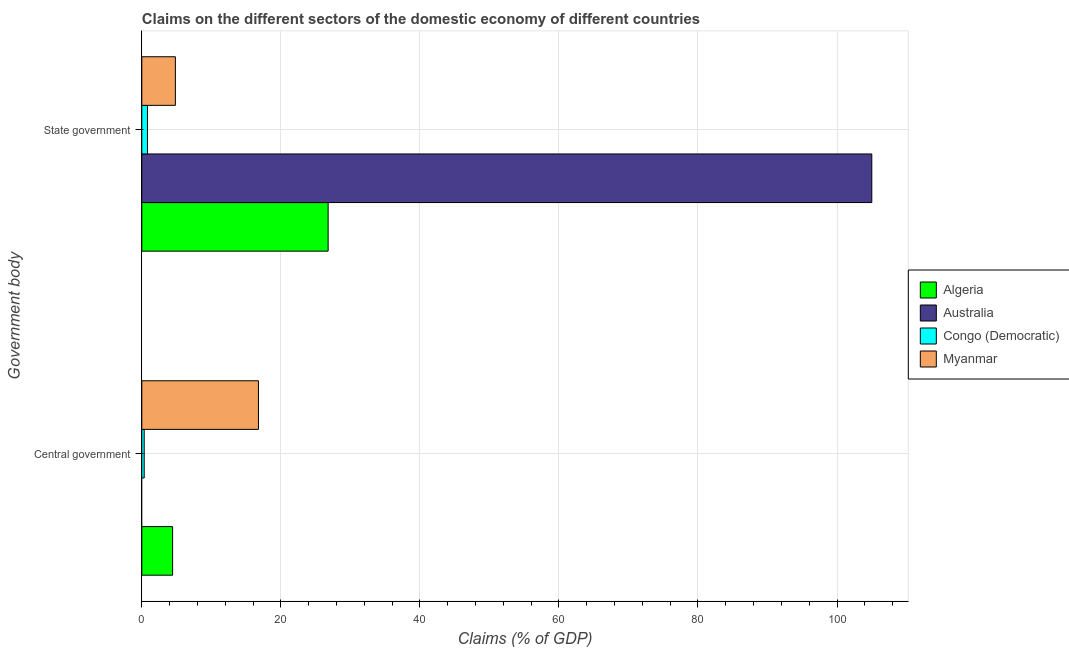How many different coloured bars are there?
Keep it short and to the point. 4. How many groups of bars are there?
Make the answer very short. 2. Are the number of bars per tick equal to the number of legend labels?
Provide a succinct answer. No. How many bars are there on the 1st tick from the bottom?
Your answer should be very brief. 3. What is the label of the 1st group of bars from the top?
Your answer should be very brief. State government. What is the claims on state government in Australia?
Ensure brevity in your answer.  105. Across all countries, what is the maximum claims on central government?
Keep it short and to the point. 16.78. Across all countries, what is the minimum claims on state government?
Provide a short and direct response. 0.81. In which country was the claims on state government maximum?
Offer a very short reply. Australia. What is the total claims on central government in the graph?
Provide a succinct answer. 21.56. What is the difference between the claims on state government in Myanmar and that in Australia?
Your response must be concise. -100.17. What is the difference between the claims on central government in Congo (Democratic) and the claims on state government in Algeria?
Make the answer very short. -26.46. What is the average claims on state government per country?
Provide a short and direct response. 34.36. What is the difference between the claims on central government and claims on state government in Congo (Democratic)?
Keep it short and to the point. -0.47. In how many countries, is the claims on central government greater than 80 %?
Ensure brevity in your answer.  0. What is the ratio of the claims on state government in Myanmar to that in Algeria?
Make the answer very short. 0.18. In how many countries, is the claims on central government greater than the average claims on central government taken over all countries?
Offer a very short reply. 1. How many bars are there?
Keep it short and to the point. 7. Are the values on the major ticks of X-axis written in scientific E-notation?
Provide a succinct answer. No. Does the graph contain grids?
Make the answer very short. Yes. Where does the legend appear in the graph?
Ensure brevity in your answer.  Center right. How many legend labels are there?
Provide a succinct answer. 4. What is the title of the graph?
Your answer should be compact. Claims on the different sectors of the domestic economy of different countries. Does "Papua New Guinea" appear as one of the legend labels in the graph?
Provide a succinct answer. No. What is the label or title of the X-axis?
Your answer should be compact. Claims (% of GDP). What is the label or title of the Y-axis?
Make the answer very short. Government body. What is the Claims (% of GDP) in Algeria in Central government?
Keep it short and to the point. 4.43. What is the Claims (% of GDP) in Congo (Democratic) in Central government?
Offer a terse response. 0.35. What is the Claims (% of GDP) of Myanmar in Central government?
Your answer should be very brief. 16.78. What is the Claims (% of GDP) of Algeria in State government?
Keep it short and to the point. 26.8. What is the Claims (% of GDP) in Australia in State government?
Provide a short and direct response. 105. What is the Claims (% of GDP) of Congo (Democratic) in State government?
Provide a short and direct response. 0.81. What is the Claims (% of GDP) in Myanmar in State government?
Offer a very short reply. 4.83. Across all Government body, what is the maximum Claims (% of GDP) in Algeria?
Keep it short and to the point. 26.8. Across all Government body, what is the maximum Claims (% of GDP) of Australia?
Your answer should be compact. 105. Across all Government body, what is the maximum Claims (% of GDP) of Congo (Democratic)?
Ensure brevity in your answer.  0.81. Across all Government body, what is the maximum Claims (% of GDP) in Myanmar?
Offer a very short reply. 16.78. Across all Government body, what is the minimum Claims (% of GDP) of Algeria?
Your response must be concise. 4.43. Across all Government body, what is the minimum Claims (% of GDP) of Congo (Democratic)?
Offer a very short reply. 0.35. Across all Government body, what is the minimum Claims (% of GDP) of Myanmar?
Your answer should be very brief. 4.83. What is the total Claims (% of GDP) of Algeria in the graph?
Provide a succinct answer. 31.24. What is the total Claims (% of GDP) in Australia in the graph?
Make the answer very short. 105. What is the total Claims (% of GDP) of Congo (Democratic) in the graph?
Offer a very short reply. 1.16. What is the total Claims (% of GDP) in Myanmar in the graph?
Provide a short and direct response. 21.61. What is the difference between the Claims (% of GDP) of Algeria in Central government and that in State government?
Give a very brief answer. -22.37. What is the difference between the Claims (% of GDP) in Congo (Democratic) in Central government and that in State government?
Your answer should be compact. -0.47. What is the difference between the Claims (% of GDP) in Myanmar in Central government and that in State government?
Ensure brevity in your answer.  11.95. What is the difference between the Claims (% of GDP) in Algeria in Central government and the Claims (% of GDP) in Australia in State government?
Offer a terse response. -100.57. What is the difference between the Claims (% of GDP) in Algeria in Central government and the Claims (% of GDP) in Congo (Democratic) in State government?
Provide a short and direct response. 3.62. What is the difference between the Claims (% of GDP) of Algeria in Central government and the Claims (% of GDP) of Myanmar in State government?
Make the answer very short. -0.4. What is the difference between the Claims (% of GDP) in Congo (Democratic) in Central government and the Claims (% of GDP) in Myanmar in State government?
Keep it short and to the point. -4.48. What is the average Claims (% of GDP) of Algeria per Government body?
Keep it short and to the point. 15.62. What is the average Claims (% of GDP) in Australia per Government body?
Ensure brevity in your answer.  52.5. What is the average Claims (% of GDP) of Congo (Democratic) per Government body?
Give a very brief answer. 0.58. What is the average Claims (% of GDP) in Myanmar per Government body?
Offer a terse response. 10.81. What is the difference between the Claims (% of GDP) of Algeria and Claims (% of GDP) of Congo (Democratic) in Central government?
Ensure brevity in your answer.  4.09. What is the difference between the Claims (% of GDP) in Algeria and Claims (% of GDP) in Myanmar in Central government?
Your response must be concise. -12.35. What is the difference between the Claims (% of GDP) of Congo (Democratic) and Claims (% of GDP) of Myanmar in Central government?
Make the answer very short. -16.43. What is the difference between the Claims (% of GDP) in Algeria and Claims (% of GDP) in Australia in State government?
Offer a terse response. -78.2. What is the difference between the Claims (% of GDP) of Algeria and Claims (% of GDP) of Congo (Democratic) in State government?
Your response must be concise. 25.99. What is the difference between the Claims (% of GDP) in Algeria and Claims (% of GDP) in Myanmar in State government?
Make the answer very short. 21.97. What is the difference between the Claims (% of GDP) in Australia and Claims (% of GDP) in Congo (Democratic) in State government?
Provide a short and direct response. 104.19. What is the difference between the Claims (% of GDP) in Australia and Claims (% of GDP) in Myanmar in State government?
Your response must be concise. 100.17. What is the difference between the Claims (% of GDP) in Congo (Democratic) and Claims (% of GDP) in Myanmar in State government?
Your response must be concise. -4.02. What is the ratio of the Claims (% of GDP) of Algeria in Central government to that in State government?
Make the answer very short. 0.17. What is the ratio of the Claims (% of GDP) of Congo (Democratic) in Central government to that in State government?
Your answer should be very brief. 0.43. What is the ratio of the Claims (% of GDP) of Myanmar in Central government to that in State government?
Give a very brief answer. 3.47. What is the difference between the highest and the second highest Claims (% of GDP) of Algeria?
Give a very brief answer. 22.37. What is the difference between the highest and the second highest Claims (% of GDP) in Congo (Democratic)?
Provide a succinct answer. 0.47. What is the difference between the highest and the second highest Claims (% of GDP) in Myanmar?
Give a very brief answer. 11.95. What is the difference between the highest and the lowest Claims (% of GDP) in Algeria?
Ensure brevity in your answer.  22.37. What is the difference between the highest and the lowest Claims (% of GDP) of Australia?
Give a very brief answer. 105. What is the difference between the highest and the lowest Claims (% of GDP) in Congo (Democratic)?
Give a very brief answer. 0.47. What is the difference between the highest and the lowest Claims (% of GDP) of Myanmar?
Your answer should be very brief. 11.95. 